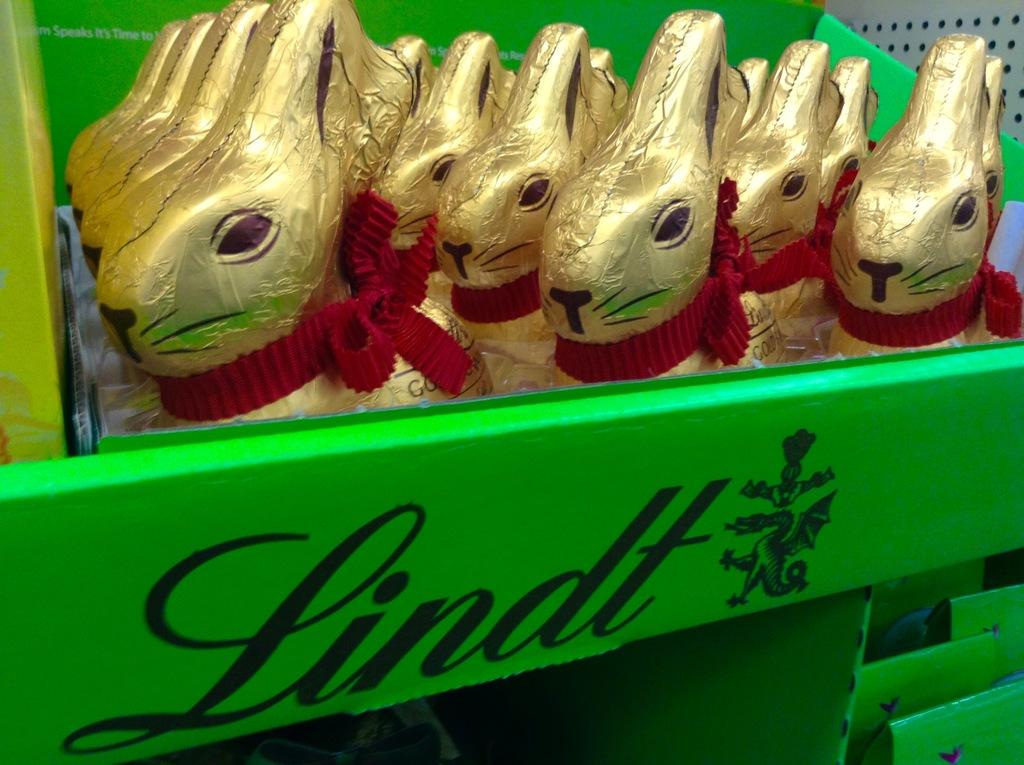What color is the box that is visible in the image? The box in the image is green. What is inside the green box? The green box contains many toys. How many buttons can be seen on the plough in the image? There is no plough or buttons present in the image; it features a green box containing toys. Can you describe the behavior of the ants in the image? There are no ants present in the image. 